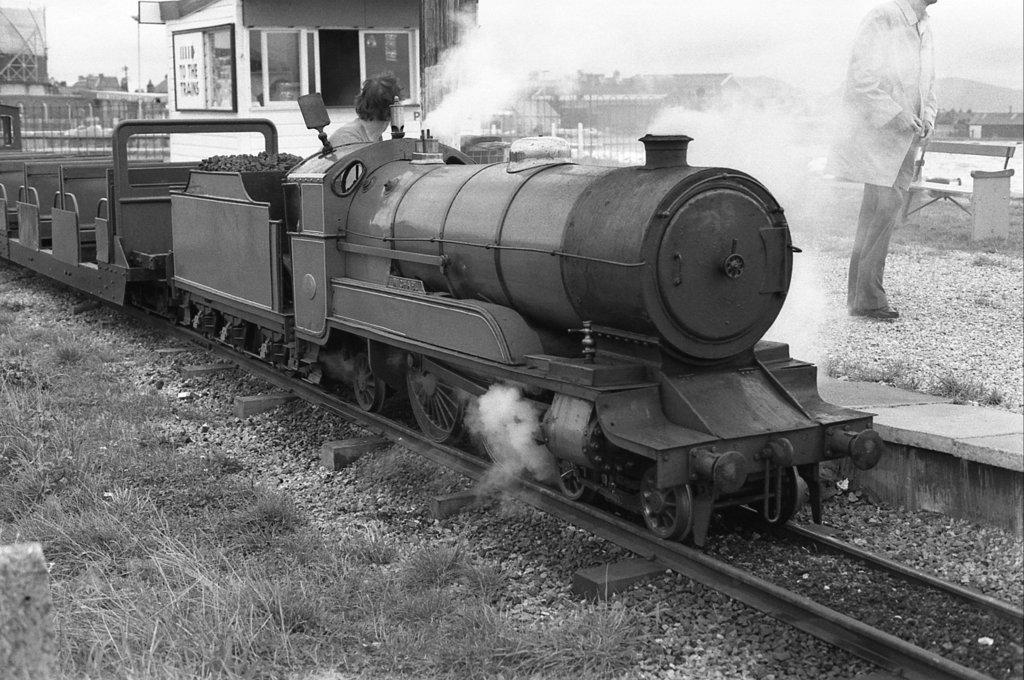<image>
Describe the image concisely. an old train, with smoke billowing from it bears a sign that says TO the trains 